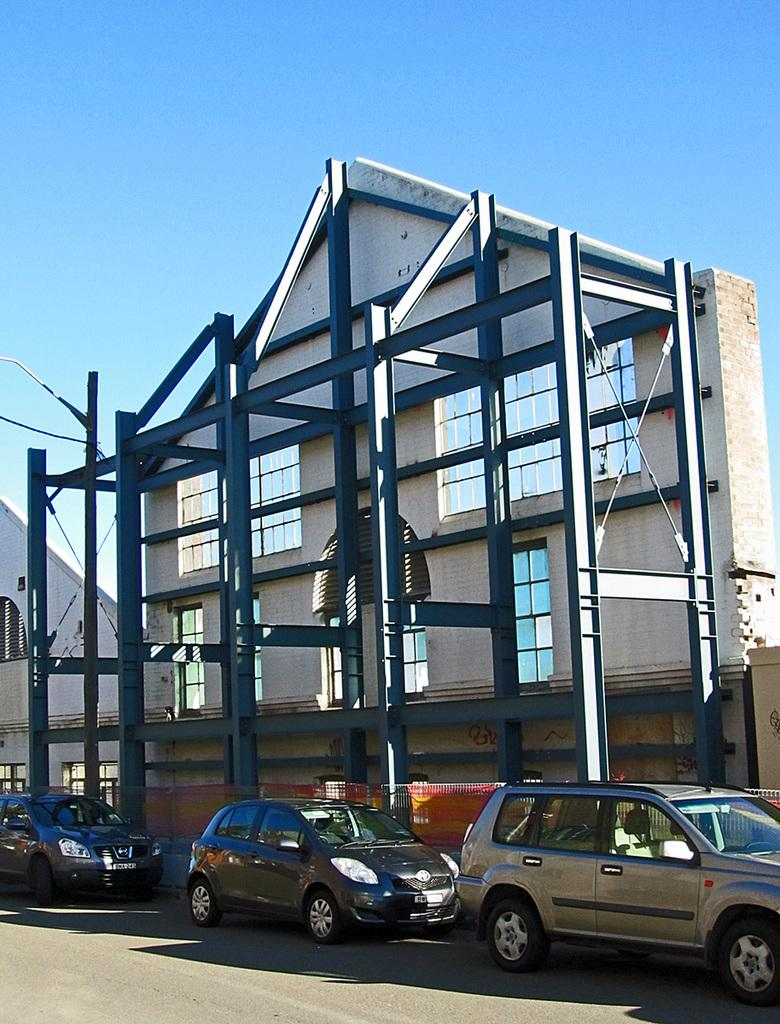What type of structure is visible in the image? There is a building in the image. What else can be seen in the image besides the building? There are rods and three cars parked on the road in the image. Where is the road located in the image? The bottom of the image contains a road. What is visible at the top of the image? The top of the image contains a blue sky. What memory does the dad share with his children in the image? There is no dad or memory shared in the image; it only contains a building, rods, cars, a road, and a blue sky. 